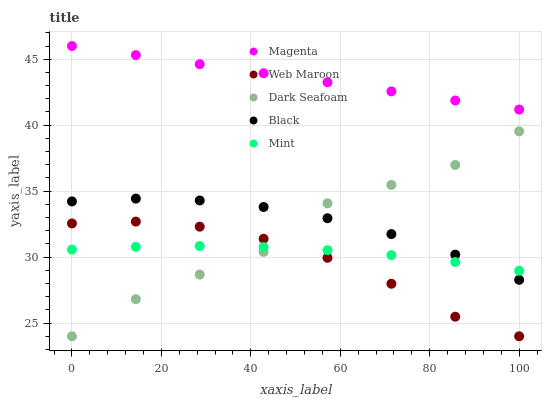Does Web Maroon have the minimum area under the curve?
Answer yes or no. Yes. Does Magenta have the maximum area under the curve?
Answer yes or no. Yes. Does Mint have the minimum area under the curve?
Answer yes or no. No. Does Mint have the maximum area under the curve?
Answer yes or no. No. Is Magenta the smoothest?
Answer yes or no. Yes. Is Dark Seafoam the roughest?
Answer yes or no. Yes. Is Mint the smoothest?
Answer yes or no. No. Is Mint the roughest?
Answer yes or no. No. Does Web Maroon have the lowest value?
Answer yes or no. Yes. Does Mint have the lowest value?
Answer yes or no. No. Does Magenta have the highest value?
Answer yes or no. Yes. Does Mint have the highest value?
Answer yes or no. No. Is Web Maroon less than Black?
Answer yes or no. Yes. Is Magenta greater than Dark Seafoam?
Answer yes or no. Yes. Does Web Maroon intersect Mint?
Answer yes or no. Yes. Is Web Maroon less than Mint?
Answer yes or no. No. Is Web Maroon greater than Mint?
Answer yes or no. No. Does Web Maroon intersect Black?
Answer yes or no. No. 